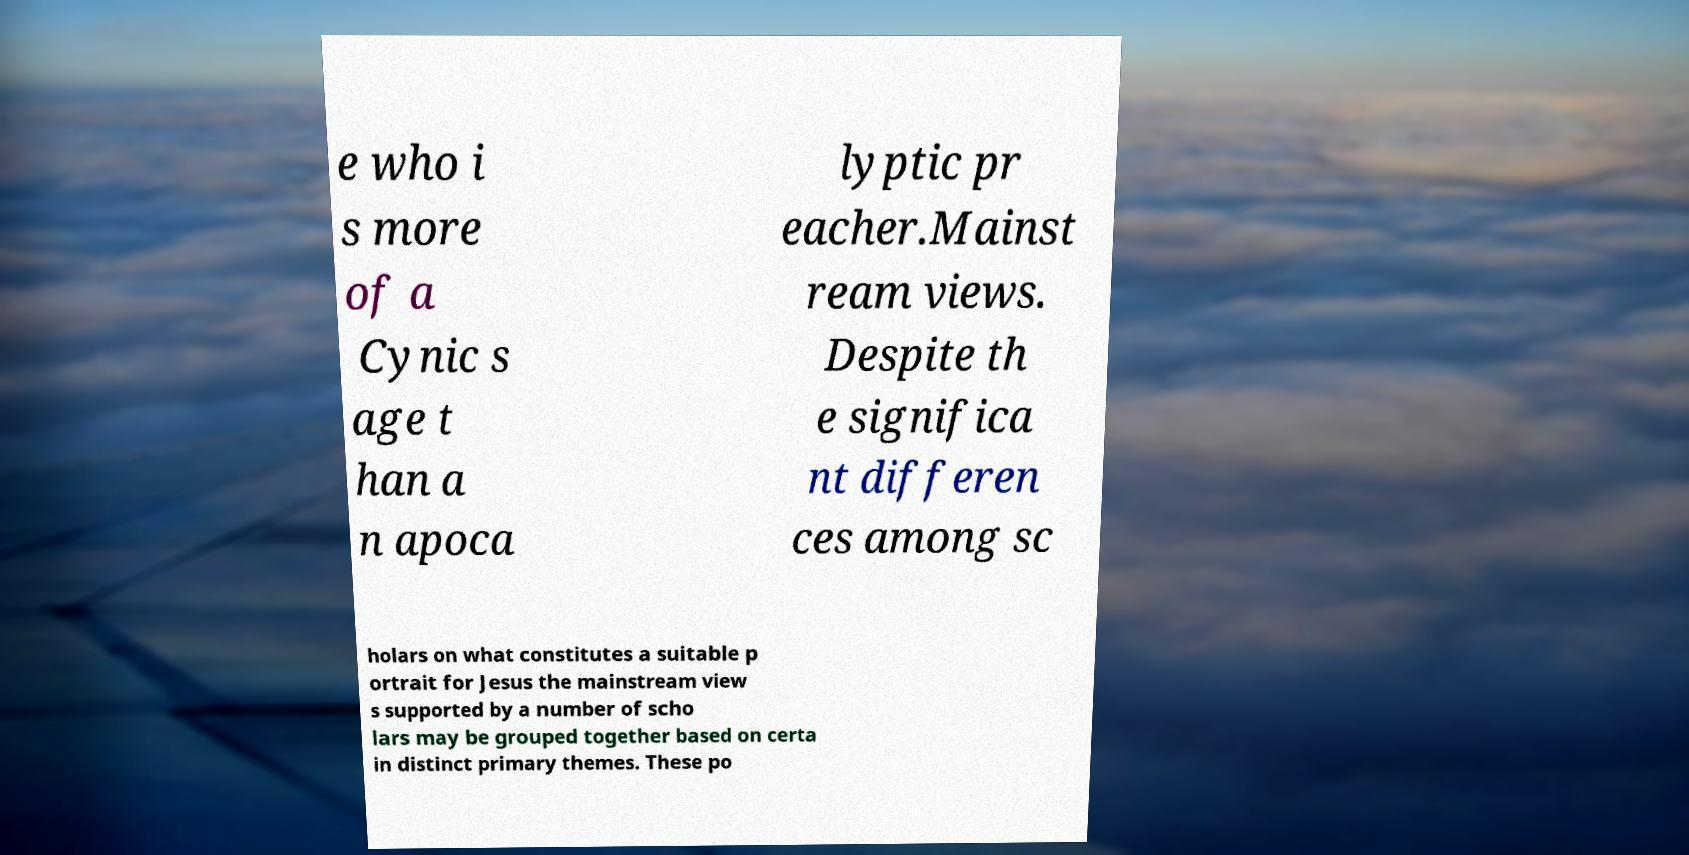Can you accurately transcribe the text from the provided image for me? e who i s more of a Cynic s age t han a n apoca lyptic pr eacher.Mainst ream views. Despite th e significa nt differen ces among sc holars on what constitutes a suitable p ortrait for Jesus the mainstream view s supported by a number of scho lars may be grouped together based on certa in distinct primary themes. These po 